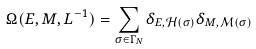Convert formula to latex. <formula><loc_0><loc_0><loc_500><loc_500>\Omega ( E , M , L ^ { - 1 } ) = \sum _ { \sigma \in \Gamma _ { N } } \delta _ { E , \mathcal { H } ( \sigma ) } \delta _ { M , \mathcal { M } ( \sigma ) }</formula> 